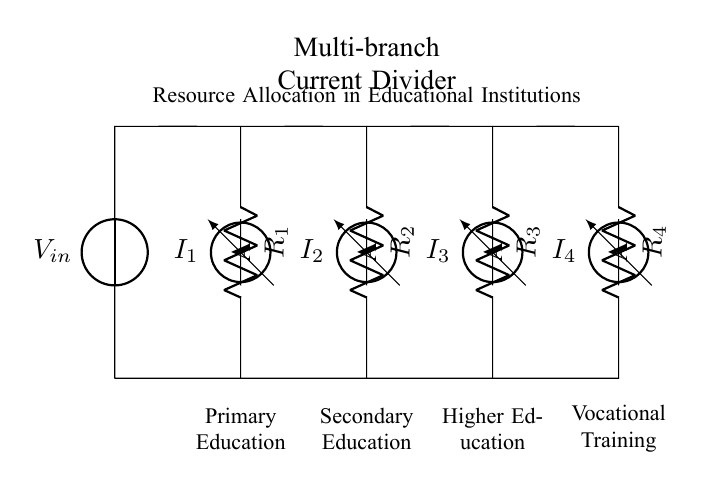What is the input voltage of this circuit? The input voltage is denoted as V_in in the schematic. There is no specific value provided in the diagram, but it represents the voltage supplied to the current divider.
Answer: V_in How many resistors are present in the circuit? There are four resistors shown in the circuit diagram, labeled as R_1, R_2, R_3, and R_4. Each represents a different educational sector.
Answer: 4 Which educational sector does R_2 represent? R_2 is labeled in the diagram as representing Secondary Education. This is indicated by the text positioned below the resistor.
Answer: Secondary Education What is the role of the ammeters in the circuit? The ammeters, labeled as I_1, I_2, I_3, and I_4, measure the current flowing through each branch corresponding to the educational sectors, indicating the current distribution in the multi-branch circuit.
Answer: Measure current If the resistance of R_1 is doubled, what effect does it have on I_1? According to the current division principle, if R_1 is increased, I_1 will decrease since the current divides inversely proportional to the resistances in parallel. Thus, doubling R_1 would reduce I_1.
Answer: Decrease What does the term "Multi-branch Current Divider" imply in this context? The term refers to a configuration where a single input current is divided among multiple branches (educational sectors in this case), each with distinct resistances, allowing analysis of resource allocation.
Answer: Resource allocation Which branch has the lowest resistance? In a current divider, the branch with the lowest resistance will have the highest current flowing through it. By visual inspection of the circuit diagram, the specific branch is not labeled with actual resistance values, but it is typically inferred through context.
Answer: Depends on resistance values 